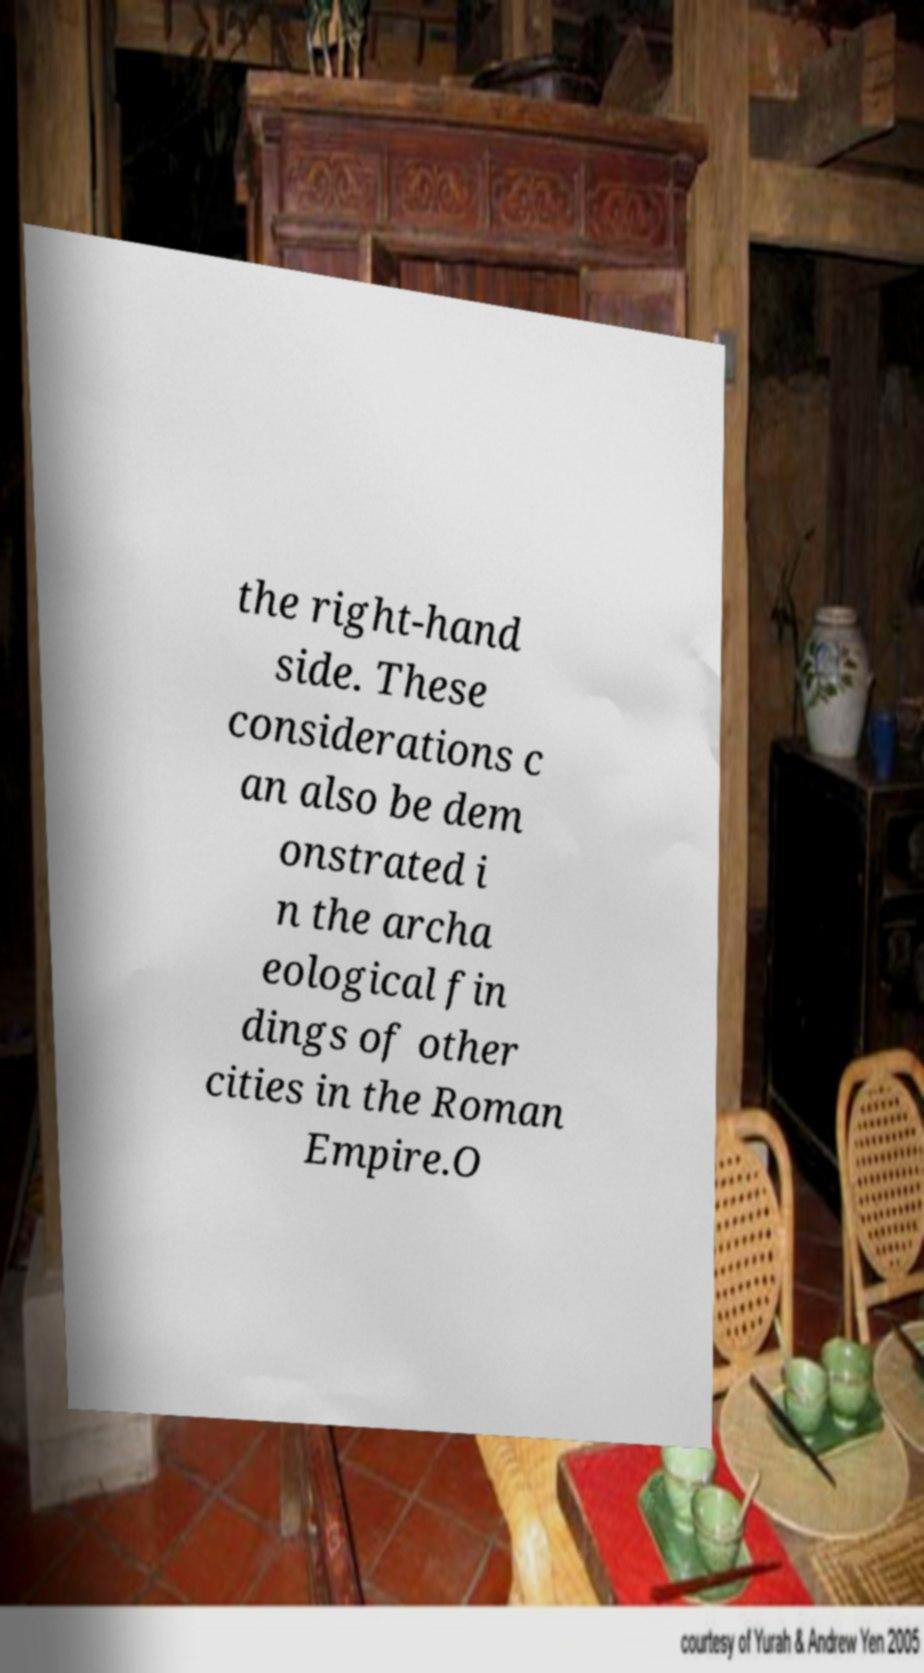Please identify and transcribe the text found in this image. the right-hand side. These considerations c an also be dem onstrated i n the archa eological fin dings of other cities in the Roman Empire.O 